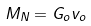<formula> <loc_0><loc_0><loc_500><loc_500>M _ { N } = G _ { o } v _ { o }</formula> 